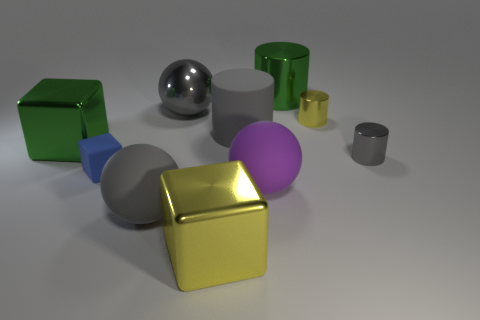Subtract all cyan cubes. How many gray cylinders are left? 2 Subtract 1 blocks. How many blocks are left? 2 Subtract all yellow cylinders. How many cylinders are left? 3 Subtract all big blocks. How many blocks are left? 1 Subtract all yellow spheres. Subtract all purple cylinders. How many spheres are left? 3 Subtract all cylinders. How many objects are left? 6 Subtract all green matte cylinders. Subtract all gray matte cylinders. How many objects are left? 9 Add 2 yellow objects. How many yellow objects are left? 4 Add 8 tiny matte objects. How many tiny matte objects exist? 9 Subtract 1 gray cylinders. How many objects are left? 9 